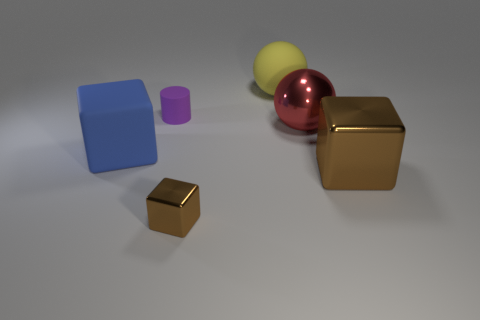Subtract all big blocks. How many blocks are left? 1 Subtract all red cylinders. How many brown cubes are left? 2 Add 4 large rubber objects. How many objects exist? 10 Subtract all cylinders. How many objects are left? 5 Add 6 rubber objects. How many rubber objects are left? 9 Add 1 red rubber cylinders. How many red rubber cylinders exist? 1 Subtract 0 yellow blocks. How many objects are left? 6 Subtract all big brown cubes. Subtract all large blue blocks. How many objects are left? 4 